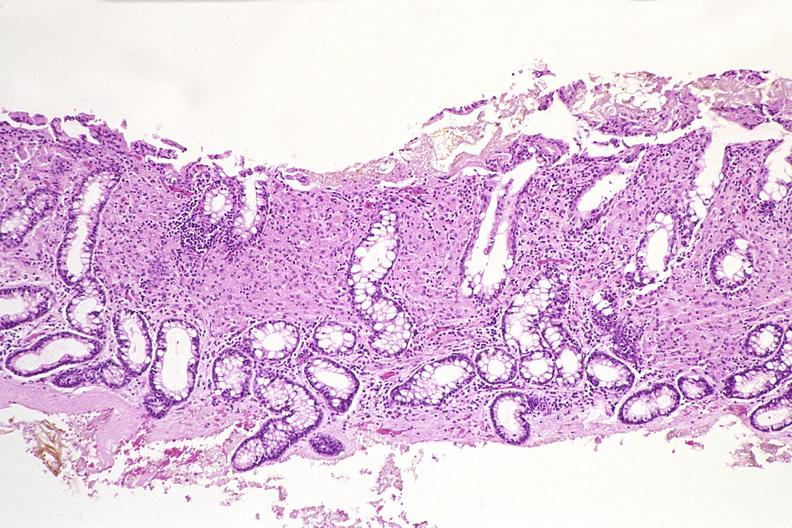does intrauterine contraceptive device show colon biopsy, mycobacterium avium-intracellularae?
Answer the question using a single word or phrase. No 